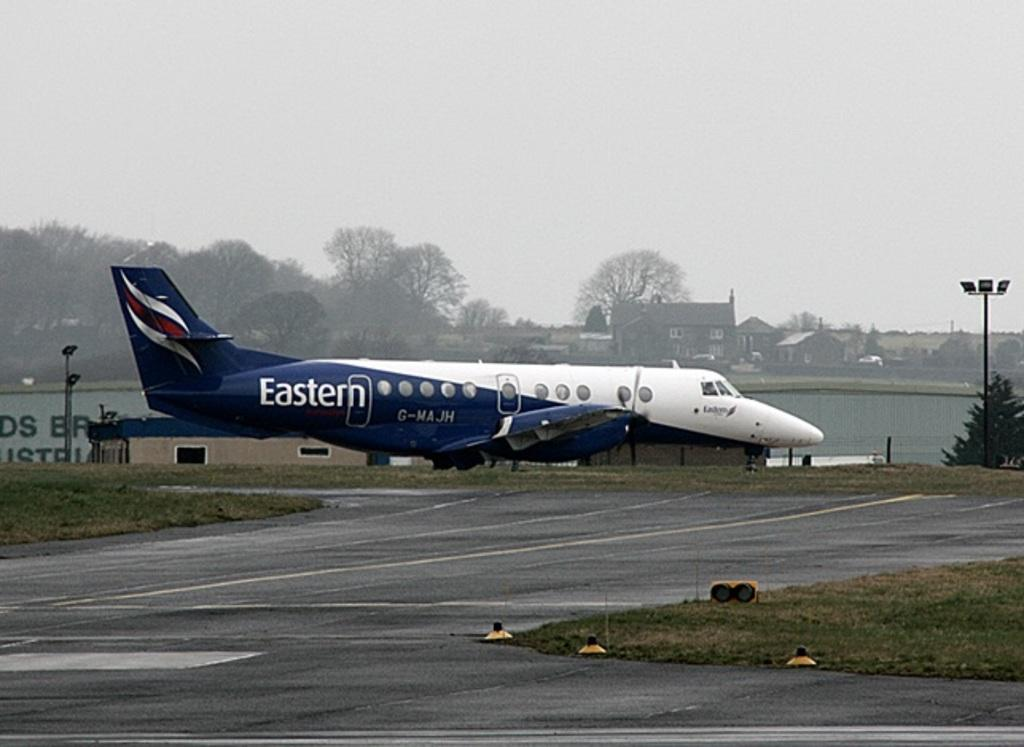Provide a one-sentence caption for the provided image. An Eastern plane sits on the airport runway. 